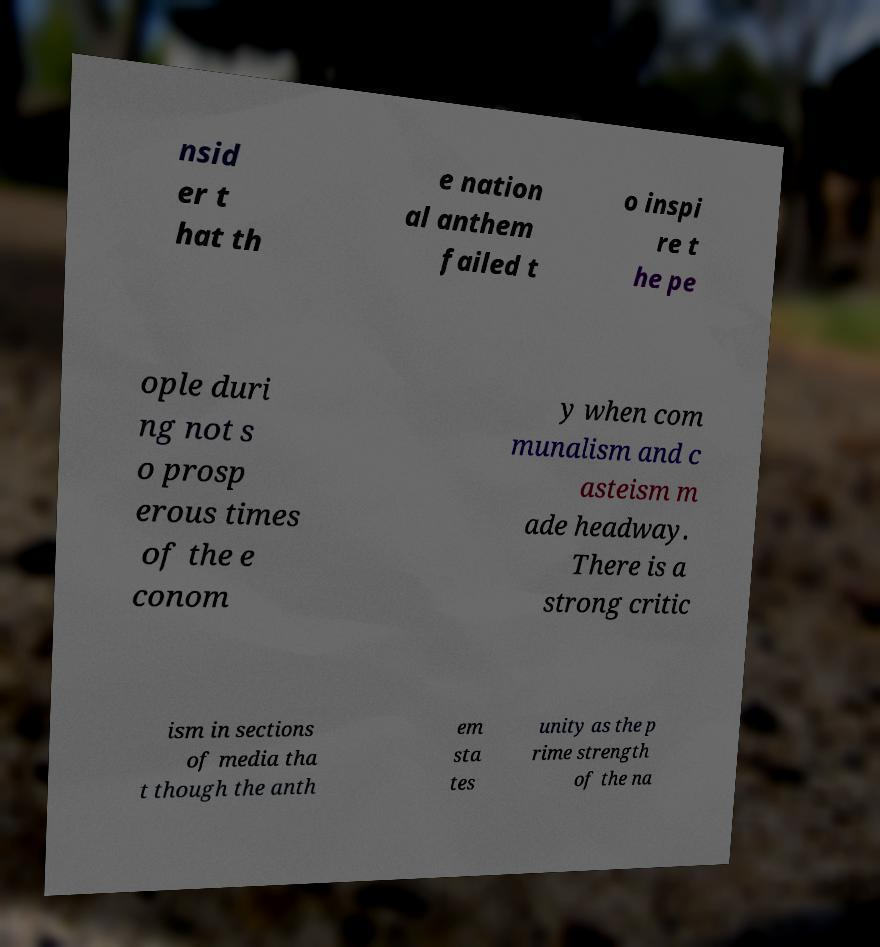I need the written content from this picture converted into text. Can you do that? nsid er t hat th e nation al anthem failed t o inspi re t he pe ople duri ng not s o prosp erous times of the e conom y when com munalism and c asteism m ade headway. There is a strong critic ism in sections of media tha t though the anth em sta tes unity as the p rime strength of the na 